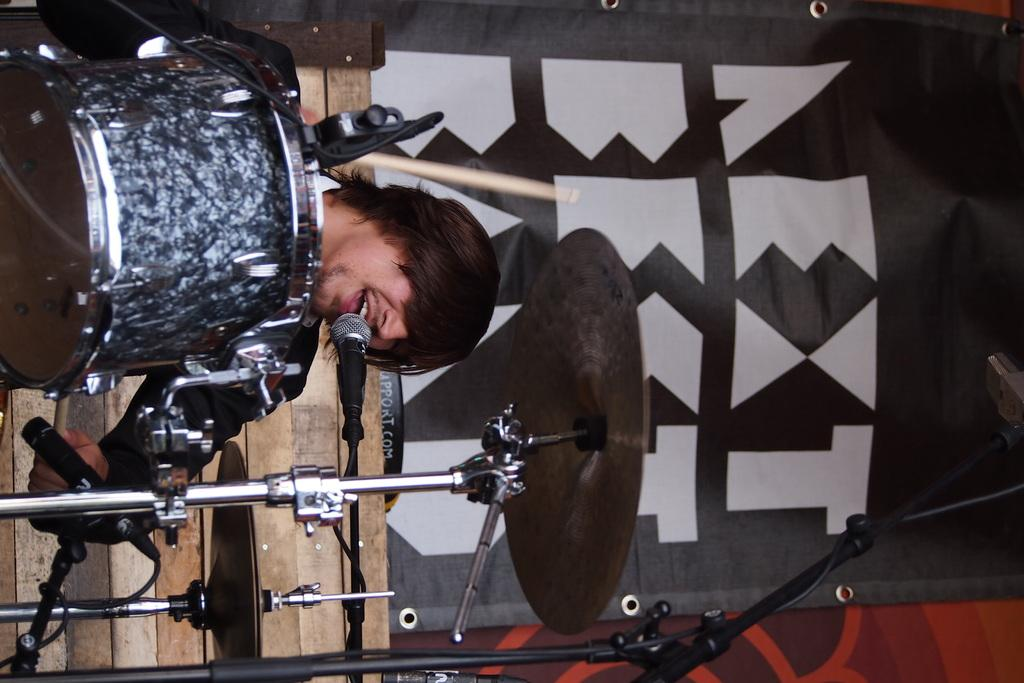What is the man in the image doing? The man is singing on a microphone. What instrument can be seen on the left side of the image? There is a snare drum musical arrangement on the left side of the image. What color and type of object is on the right side of the image? There is a black color banner on the right side of the image. What type of wool is being used to make the seed in the image? There is no wool or seed present in the image. How many cats can be seen playing with the microphone in the image? There are no cats present in the image; the man is singing on the microphone. 